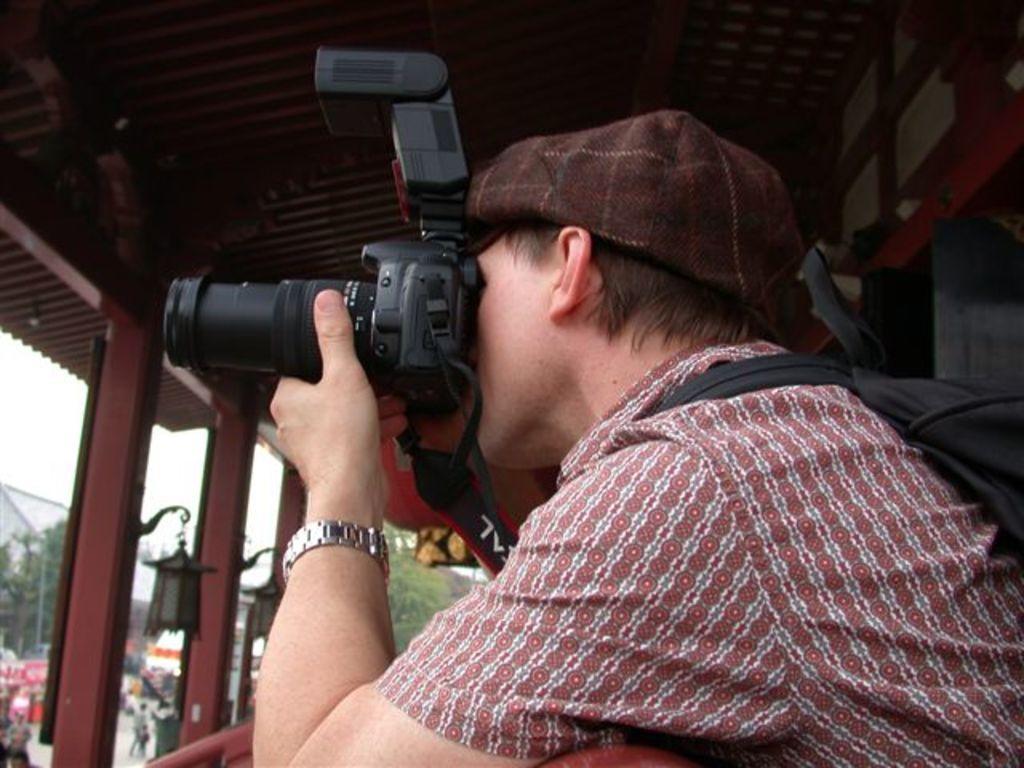Describe this image in one or two sentences. In this image i can see a person wearing a red color shirt and taking a picture to the camera and wearing back pack and left side i can see a trees and there are the some persons walking on the road and there is a lamp attached to the beam. 